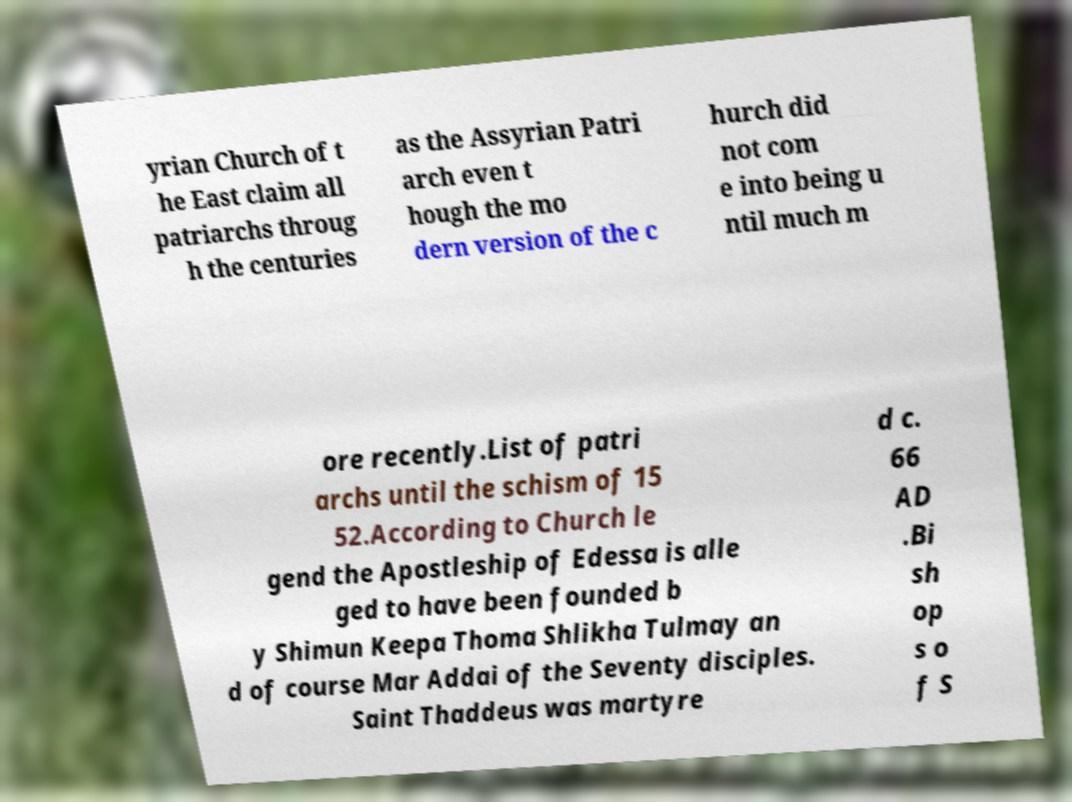Please identify and transcribe the text found in this image. yrian Church of t he East claim all patriarchs throug h the centuries as the Assyrian Patri arch even t hough the mo dern version of the c hurch did not com e into being u ntil much m ore recently.List of patri archs until the schism of 15 52.According to Church le gend the Apostleship of Edessa is alle ged to have been founded b y Shimun Keepa Thoma Shlikha Tulmay an d of course Mar Addai of the Seventy disciples. Saint Thaddeus was martyre d c. 66 AD .Bi sh op s o f S 